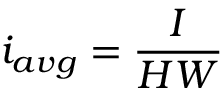Convert formula to latex. <formula><loc_0><loc_0><loc_500><loc_500>i _ { a v g } = \frac { I } { H W }</formula> 